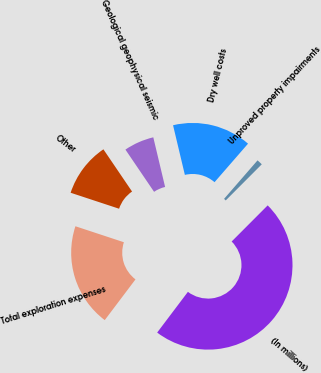<chart> <loc_0><loc_0><loc_500><loc_500><pie_chart><fcel>(In millions)<fcel>Unproved property impairments<fcel>Dry well costs<fcel>Geological geophysical seismic<fcel>Other<fcel>Total exploration expenses<nl><fcel>47.81%<fcel>1.09%<fcel>15.11%<fcel>5.77%<fcel>10.44%<fcel>19.78%<nl></chart> 